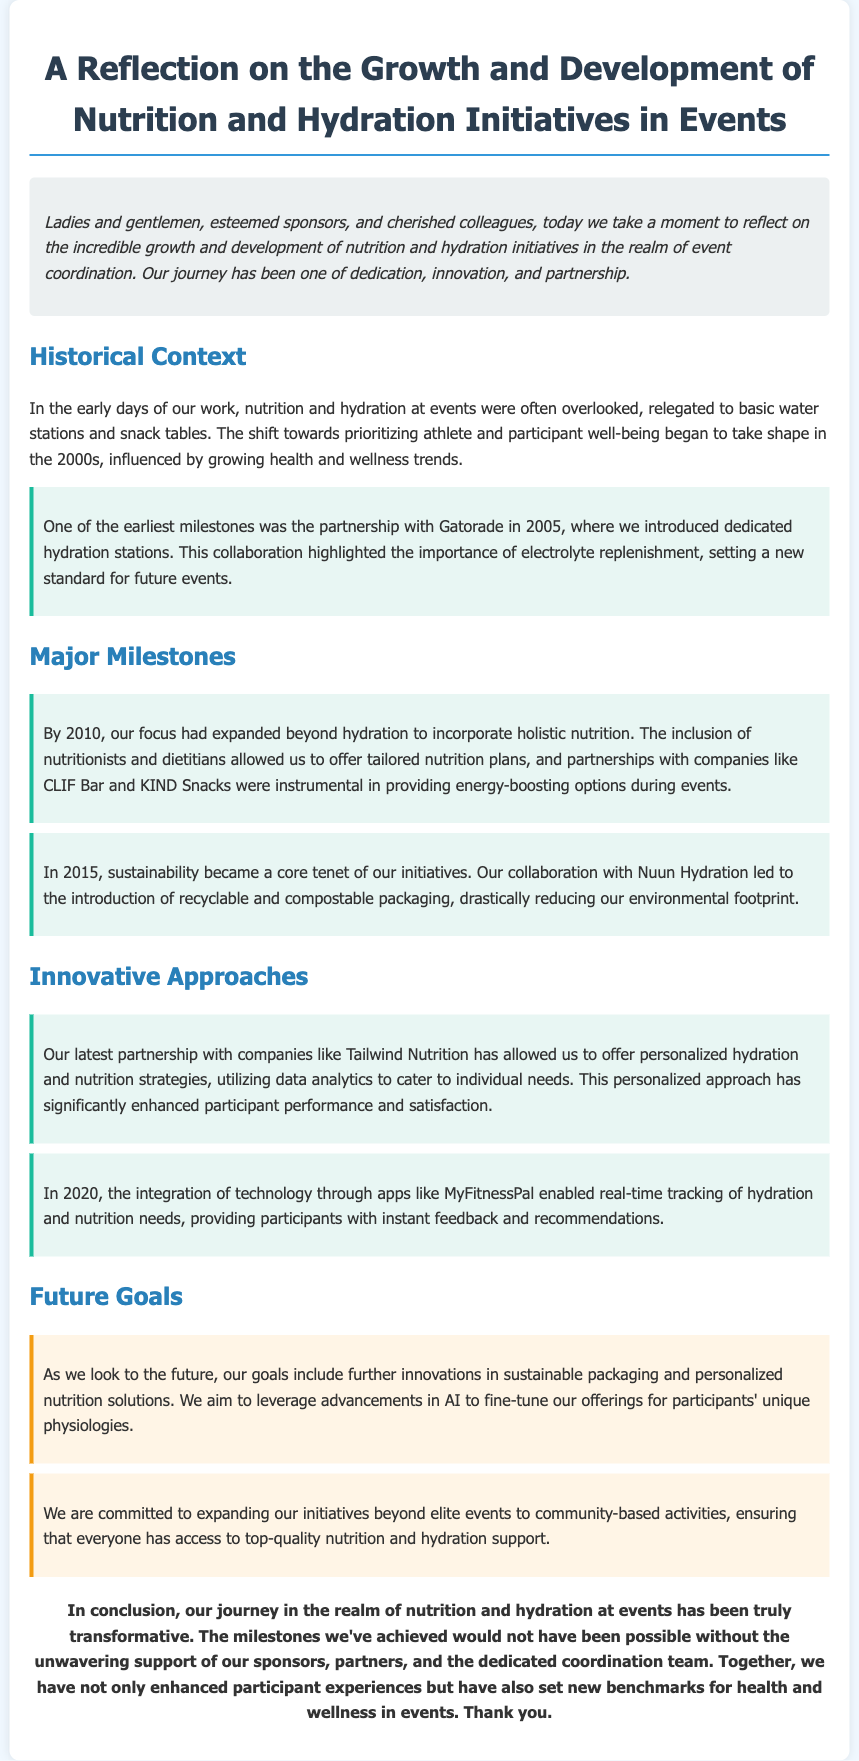what year did the partnership with Gatorade start? The document states that the partnership with Gatorade was established in 2005, marking an important milestone for nutrition and hydration initiatives.
Answer: 2005 what was introduced in 2010? In 2010, the focus expanded to include holistic nutrition with the involvement of nutritionists and dietitians.
Answer: holistic nutrition which company collaborated on sustainable packaging in 2015? The collaboration with Nuun Hydration in 2015 led to the introduction of recyclable and compostable packaging.
Answer: Nuun Hydration what app was integrated in 2020 for real-time tracking? The document mentions that MyFitnessPal was used for real-time tracking of hydration and nutrition needs in 2020.
Answer: MyFitnessPal what is a future goal mentioned in the document? One future goal includes leveraging advancements in AI to fine-tune offerings for participants' unique physiologies.
Answer: AI how many major milestones are listed in the document? There are five major milestones highlighted in the document regarding the development of nutrition and hydration initiatives.
Answer: five what core tenet emerged in 2015? The core tenet introduced in 2015 was sustainability, focusing on reducing environmental impact through packaging innovations.
Answer: sustainability what is emphasized as important for future initiatives? The future initiatives emphasize expanding beyond elite events to community-based activities.
Answer: community-based activities 